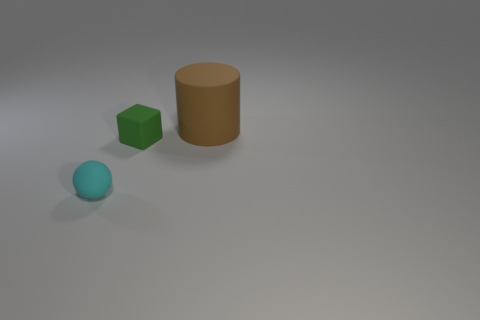Is the size of the thing that is right of the green matte cube the same as the object on the left side of the block?
Your answer should be compact. No. What is the color of the object behind the tiny green thing?
Ensure brevity in your answer.  Brown. What is the material of the thing left of the small rubber thing that is behind the small cyan matte thing?
Your answer should be compact. Rubber. The small cyan matte object is what shape?
Give a very brief answer. Sphere. How many matte cubes are the same size as the brown rubber thing?
Offer a very short reply. 0. Is there a cyan sphere behind the tiny matte object to the right of the tiny cyan thing?
Your answer should be very brief. No. How many blue things are either big matte objects or small rubber blocks?
Your answer should be compact. 0. What is the color of the tiny ball?
Your response must be concise. Cyan. What size is the brown cylinder that is made of the same material as the block?
Make the answer very short. Large. How many other things have the same shape as the tiny cyan rubber object?
Provide a succinct answer. 0. 